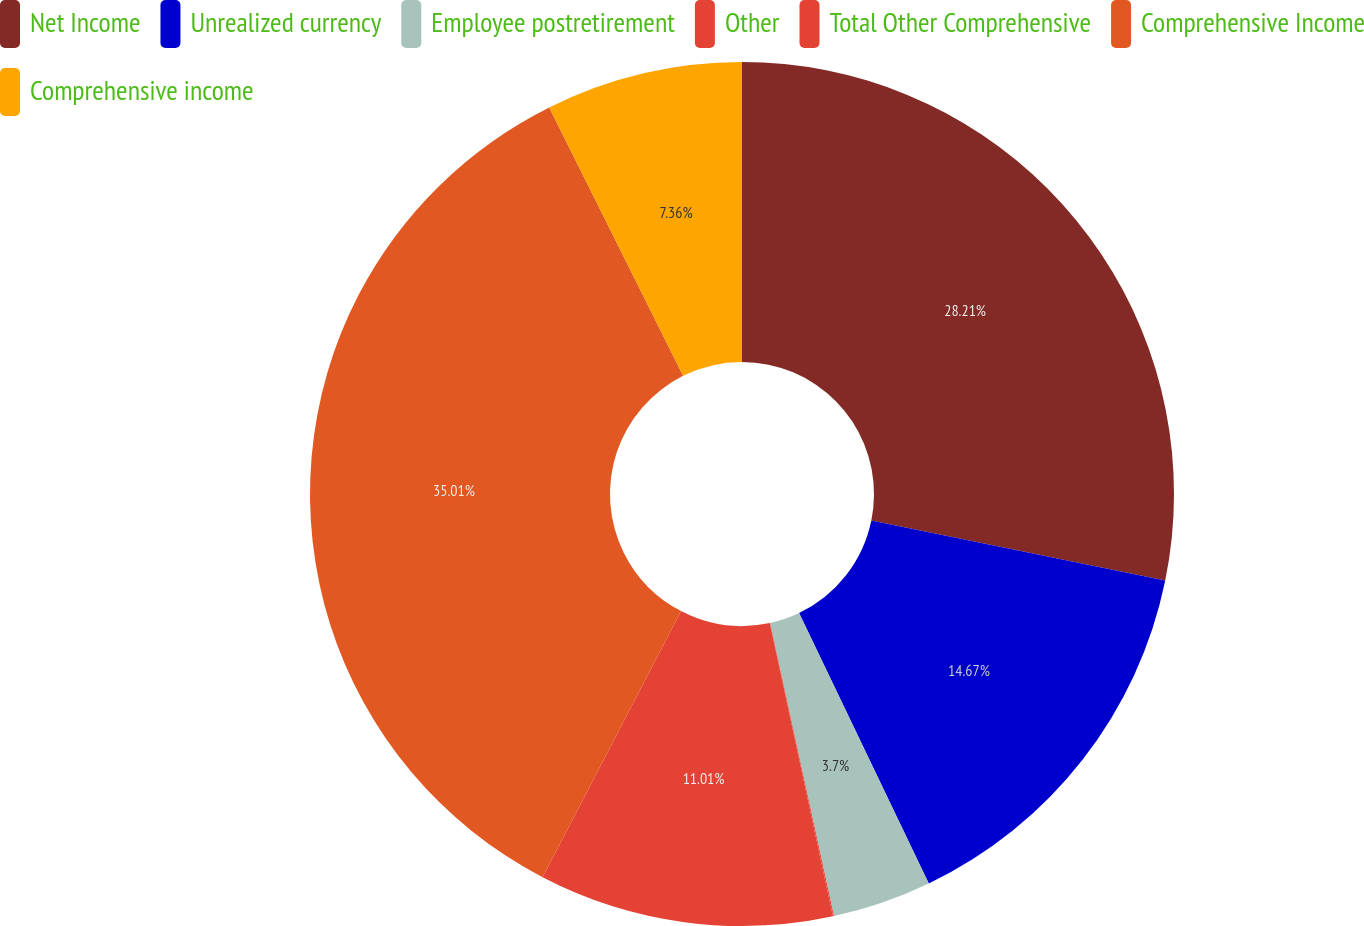<chart> <loc_0><loc_0><loc_500><loc_500><pie_chart><fcel>Net Income<fcel>Unrealized currency<fcel>Employee postretirement<fcel>Other<fcel>Total Other Comprehensive<fcel>Comprehensive Income<fcel>Comprehensive income<nl><fcel>28.21%<fcel>14.67%<fcel>3.7%<fcel>0.04%<fcel>11.01%<fcel>35.0%<fcel>7.36%<nl></chart> 